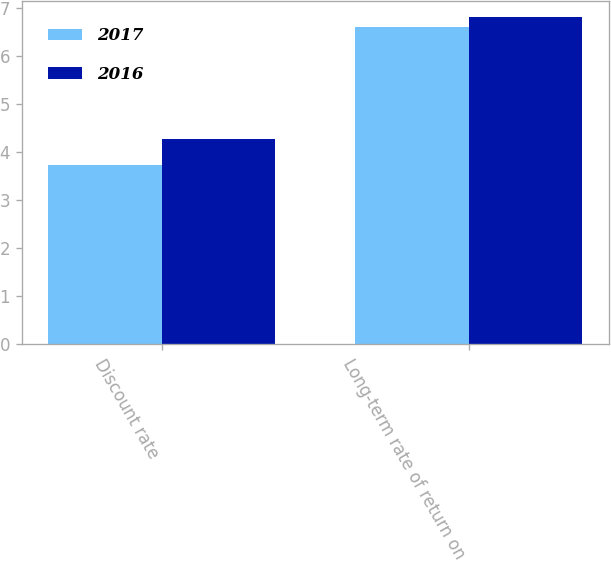Convert chart to OTSL. <chart><loc_0><loc_0><loc_500><loc_500><stacked_bar_chart><ecel><fcel>Discount rate<fcel>Long-term rate of return on<nl><fcel>2017<fcel>3.73<fcel>6.6<nl><fcel>2016<fcel>4.27<fcel>6.8<nl></chart> 